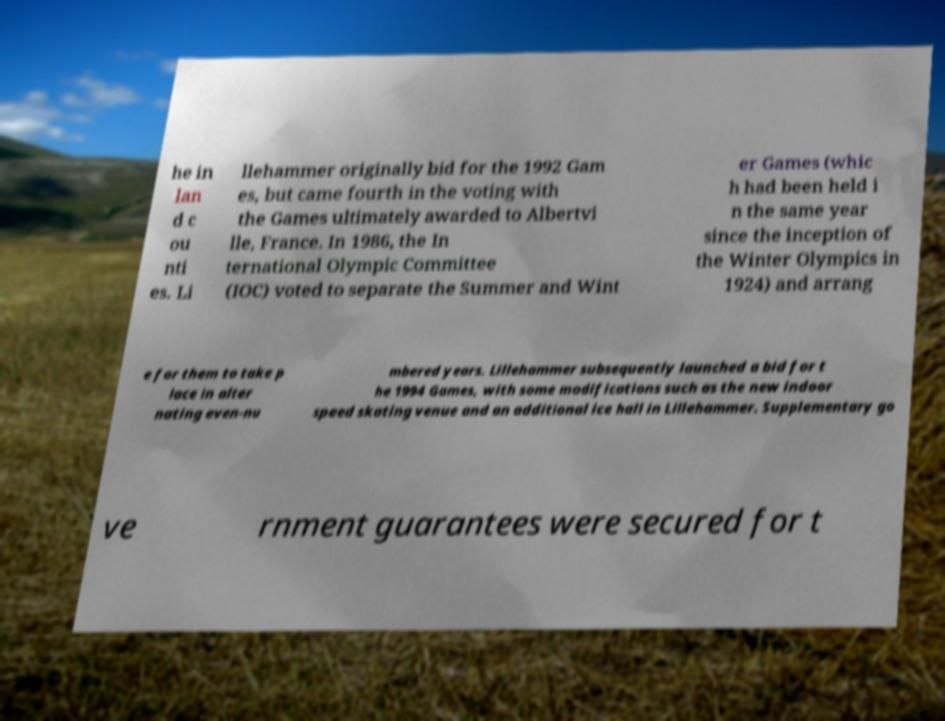Could you extract and type out the text from this image? he in lan d c ou nti es. Li llehammer originally bid for the 1992 Gam es, but came fourth in the voting with the Games ultimately awarded to Albertvi lle, France. In 1986, the In ternational Olympic Committee (IOC) voted to separate the Summer and Wint er Games (whic h had been held i n the same year since the inception of the Winter Olympics in 1924) and arrang e for them to take p lace in alter nating even-nu mbered years. Lillehammer subsequently launched a bid for t he 1994 Games, with some modifications such as the new indoor speed skating venue and an additional ice hall in Lillehammer. Supplementary go ve rnment guarantees were secured for t 